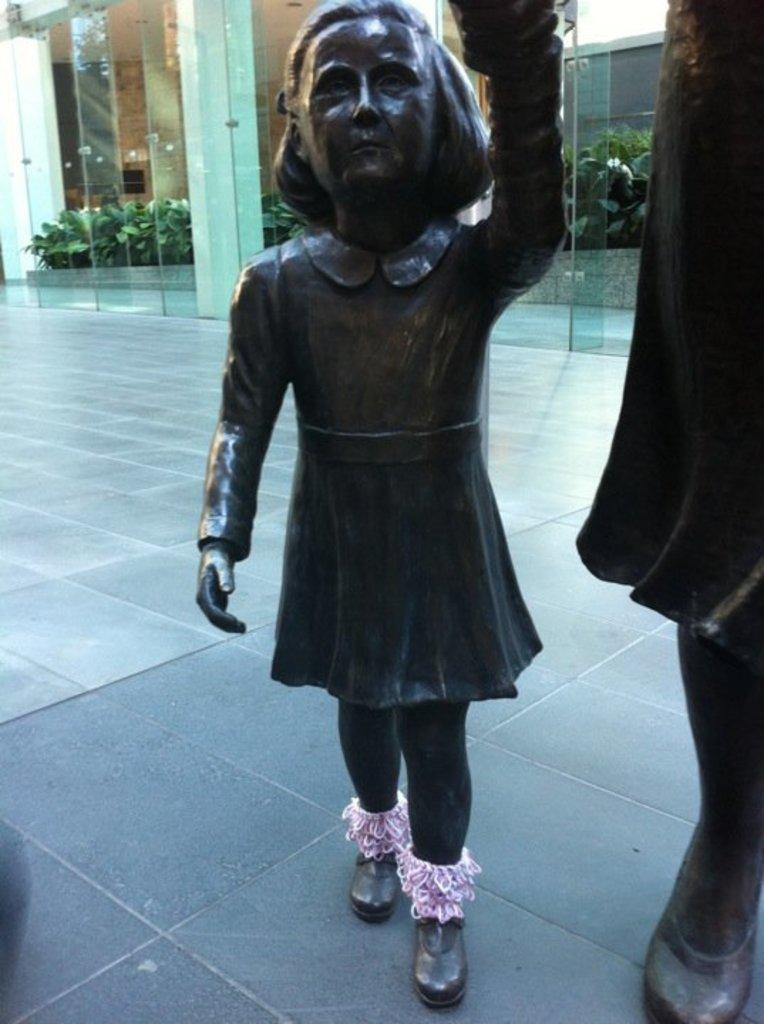What can be seen on the surface in the image? There are sculptures on the surface in the image. What is visible in the background of the image? There is glass and plants visible in the background of the image. What type of screw is being discussed in the image? There is no discussion or screw present in the image. What invention is depicted in the image? There is no invention depicted in the image; it features sculptures on a surface and glass and plants in the background. 